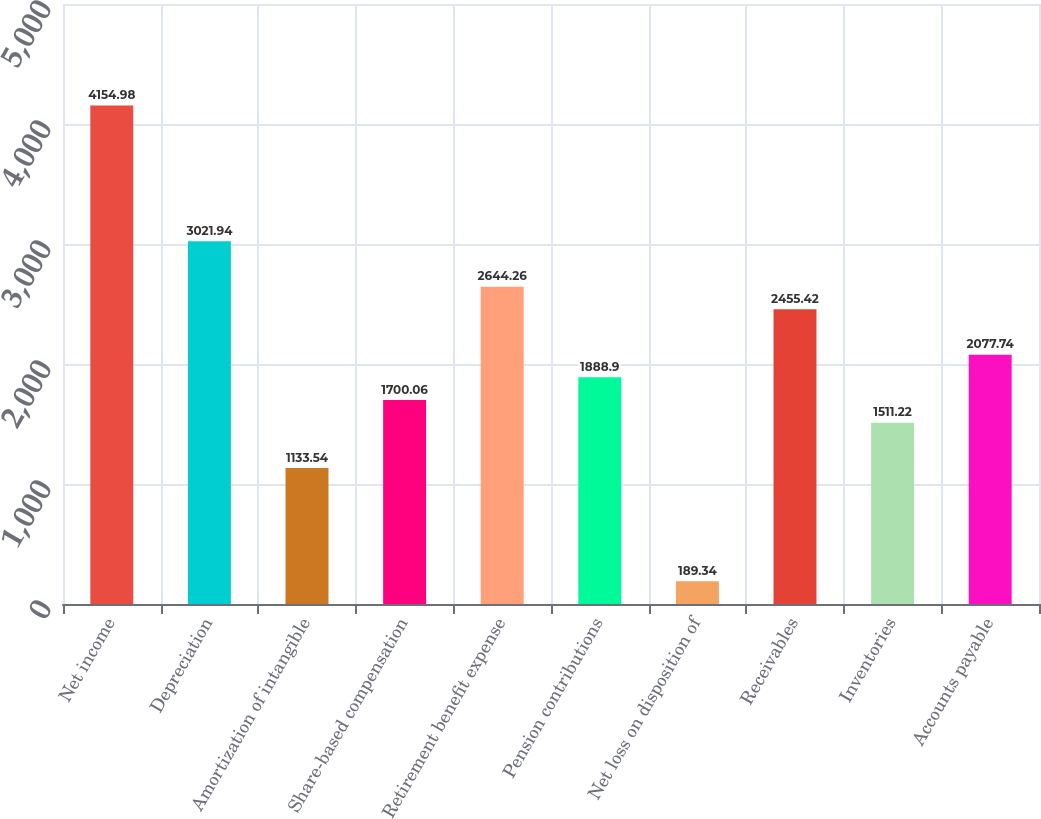<chart> <loc_0><loc_0><loc_500><loc_500><bar_chart><fcel>Net income<fcel>Depreciation<fcel>Amortization of intangible<fcel>Share-based compensation<fcel>Retirement benefit expense<fcel>Pension contributions<fcel>Net loss on disposition of<fcel>Receivables<fcel>Inventories<fcel>Accounts payable<nl><fcel>4154.98<fcel>3021.94<fcel>1133.54<fcel>1700.06<fcel>2644.26<fcel>1888.9<fcel>189.34<fcel>2455.42<fcel>1511.22<fcel>2077.74<nl></chart> 